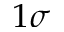<formula> <loc_0><loc_0><loc_500><loc_500>1 \sigma</formula> 